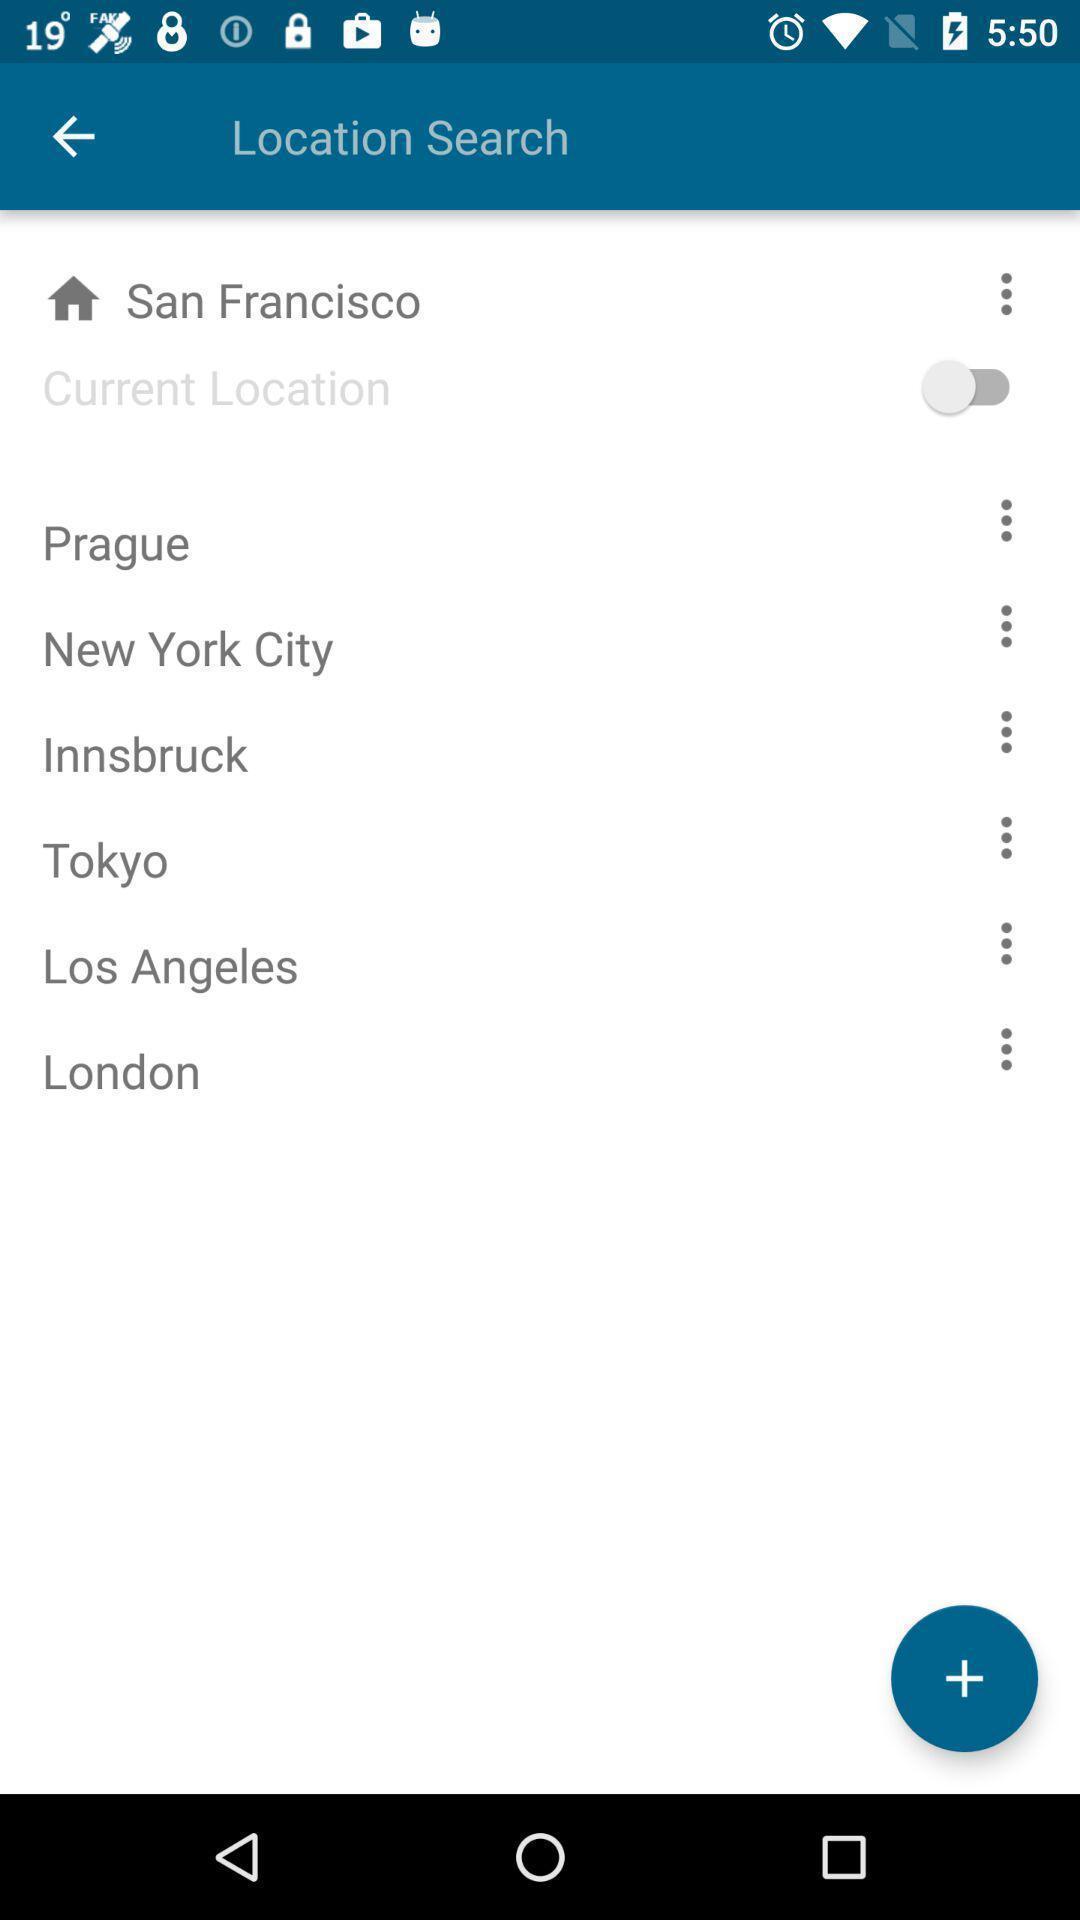Summarize the main components in this picture. Window displaying a weather app. 